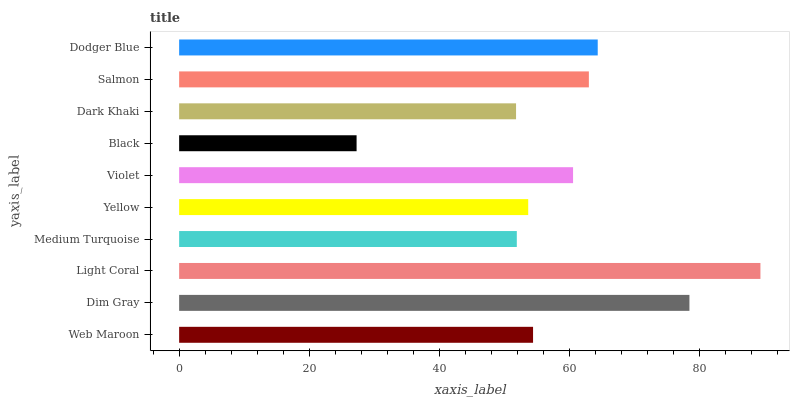Is Black the minimum?
Answer yes or no. Yes. Is Light Coral the maximum?
Answer yes or no. Yes. Is Dim Gray the minimum?
Answer yes or no. No. Is Dim Gray the maximum?
Answer yes or no. No. Is Dim Gray greater than Web Maroon?
Answer yes or no. Yes. Is Web Maroon less than Dim Gray?
Answer yes or no. Yes. Is Web Maroon greater than Dim Gray?
Answer yes or no. No. Is Dim Gray less than Web Maroon?
Answer yes or no. No. Is Violet the high median?
Answer yes or no. Yes. Is Web Maroon the low median?
Answer yes or no. Yes. Is Black the high median?
Answer yes or no. No. Is Dark Khaki the low median?
Answer yes or no. No. 